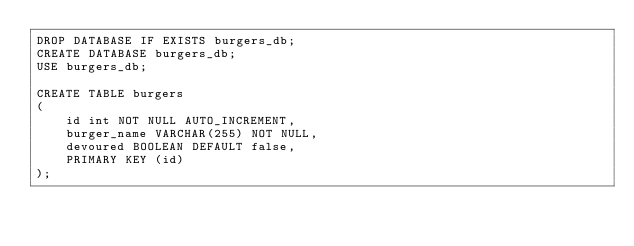Convert code to text. <code><loc_0><loc_0><loc_500><loc_500><_SQL_>DROP DATABASE IF EXISTS burgers_db;
CREATE DATABASE burgers_db;
USE burgers_db;

CREATE TABLE burgers
(
	id int NOT NULL AUTO_INCREMENT,
	burger_name VARCHAR(255) NOT NULL,
	devoured BOOLEAN DEFAULT false,
	PRIMARY KEY (id)
);
</code> 